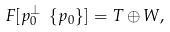Convert formula to latex. <formula><loc_0><loc_0><loc_500><loc_500>\ F [ p _ { 0 } ^ { \perp } \ \{ p _ { 0 } \} ] = T \oplus W ,</formula> 